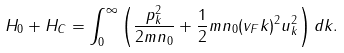Convert formula to latex. <formula><loc_0><loc_0><loc_500><loc_500>H _ { 0 } + H _ { C } = \int _ { 0 } ^ { \infty } \left ( \frac { p _ { k } ^ { 2 } } { 2 m n _ { 0 } } + \frac { 1 } { 2 } m n _ { 0 } ( v _ { F } k ) ^ { 2 } u _ { k } ^ { 2 } \right ) d k .</formula> 